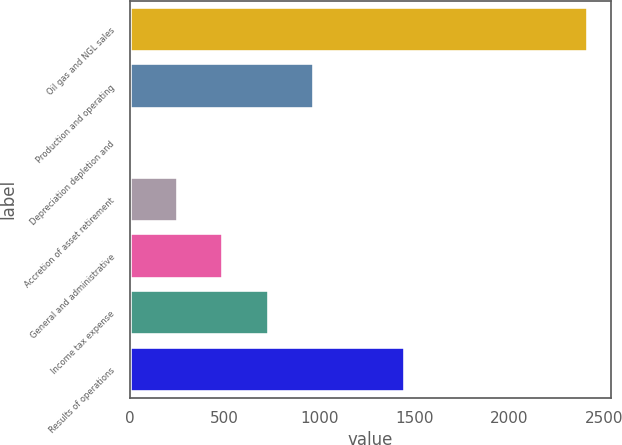<chart> <loc_0><loc_0><loc_500><loc_500><bar_chart><fcel>Oil gas and NGL sales<fcel>Production and operating<fcel>Depreciation depletion and<fcel>Accretion of asset retirement<fcel>General and administrative<fcel>Income tax expense<fcel>Results of operations<nl><fcel>2411<fcel>972.05<fcel>12.73<fcel>252.56<fcel>492.39<fcel>732.22<fcel>1451.71<nl></chart> 